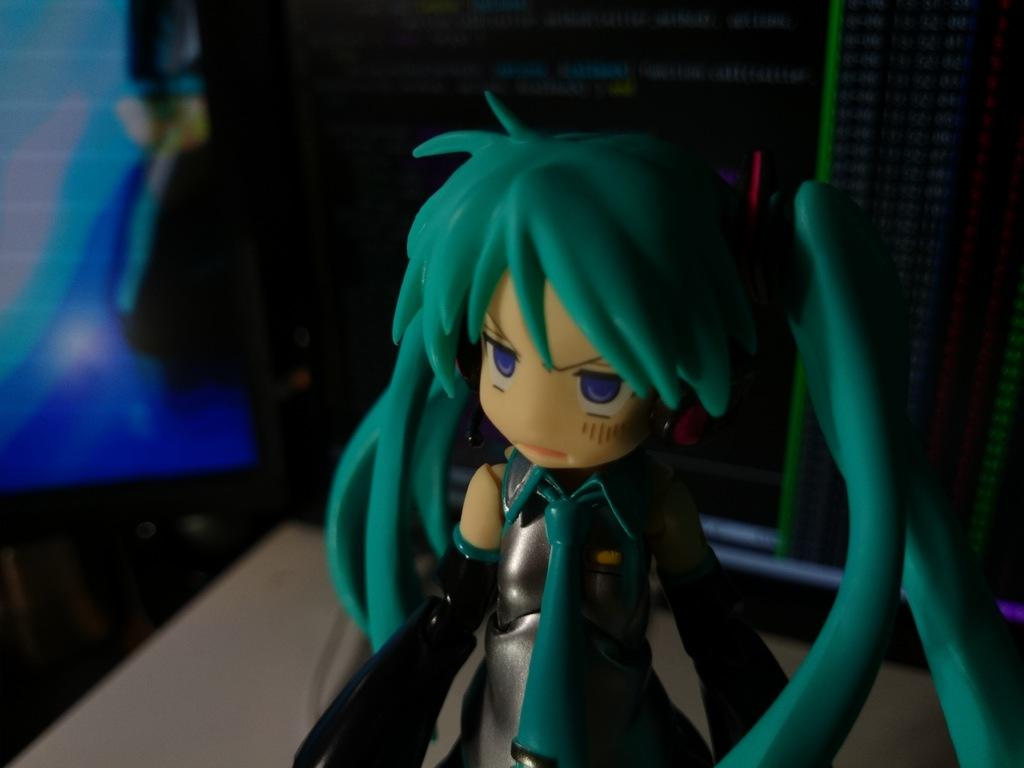What type of object is the main subject in the image? There is a colorful toy in the image. What colors can be seen in the background of the image? The background of the image is black and blue. How does the toy express its feelings in the image? Toys do not have feelings, so this question cannot be answered based on the image. 